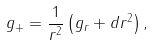Convert formula to latex. <formula><loc_0><loc_0><loc_500><loc_500>g _ { + } = \frac { 1 } { r ^ { 2 } } \left ( g _ { r } + d r ^ { 2 } \right ) ,</formula> 